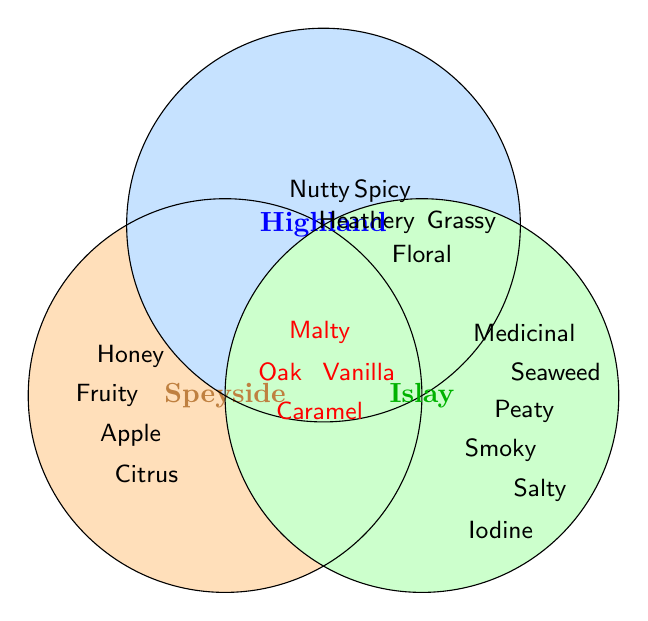Which flavor is unique to Speyside whiskies? The unique flavors of Speyside whiskies are listed in the section labeled "Speyside" only.
Answer: Fruity Which region has a medicinal flavor? The medicinal flavor is listed under the "Islay" section only.
Answer: Islay Which flavors are common to all three whisky regions? Look for the flavors listed in the central overlapping area shared by all three regions (Speyside, Highland, Islay).
Answer: Malty, Vanilla, Oak, Caramel Name a flavor that is common between Highland and Islay but not found in Speyside. Focus on the intersection between Highland and Islay regions but outside the Speyside circle.
Answer: There is no flavor common between Highland and Islay only Are there any flavors that are both peaty and nutty? Check the venn diagram for overlapping areas. There is no shared space for both peaty and nutty flavors in any region.
Answer: No Which region has the most unique flavors? Count the unique flavors listed in each region and compare.
Answer: Islay What flavor is specific to Highland but not shared with any other region? Identify flavors listed only in the Highland section and not in any intersections.
Answer: Heathery, Floral, Nutty, Spicy, Grassy Are there any sweet flavors that are common across all regions? Evaluate the overlapping section for flavors that might be sweet.
Answer: Vanilla, Caramel Which region has 'apple' as a flavor? Look for the flavor 'apple' in the specific section assigned to each whisky region.
Answer: Speyside What is the shared flavor between Speyside and Highland? Identify the overlapping section between Speyside and Highland regions.
Answer: No specific shared flavors are mentioned in that intersection 